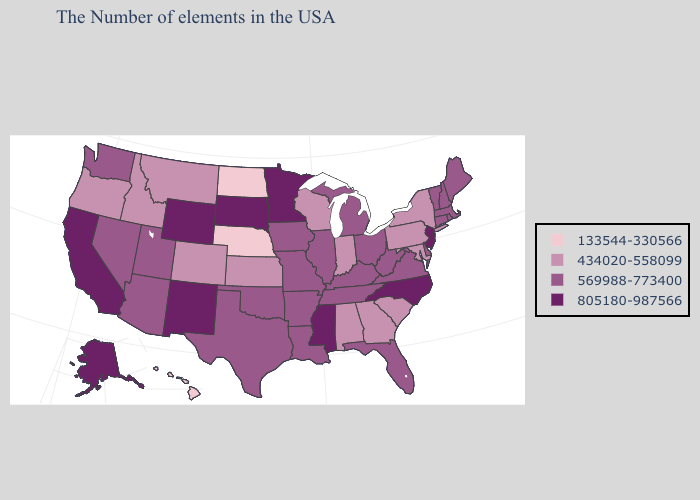Does Iowa have the same value as New York?
Be succinct. No. Name the states that have a value in the range 805180-987566?
Write a very short answer. New Jersey, North Carolina, Mississippi, Minnesota, South Dakota, Wyoming, New Mexico, California, Alaska. Which states have the lowest value in the USA?
Keep it brief. Nebraska, North Dakota, Hawaii. Name the states that have a value in the range 805180-987566?
Answer briefly. New Jersey, North Carolina, Mississippi, Minnesota, South Dakota, Wyoming, New Mexico, California, Alaska. What is the lowest value in the West?
Short answer required. 133544-330566. What is the value of Iowa?
Short answer required. 569988-773400. What is the lowest value in states that border Louisiana?
Give a very brief answer. 569988-773400. Among the states that border Oklahoma , which have the lowest value?
Write a very short answer. Kansas, Colorado. Does Illinois have the highest value in the USA?
Write a very short answer. No. Name the states that have a value in the range 805180-987566?
Write a very short answer. New Jersey, North Carolina, Mississippi, Minnesota, South Dakota, Wyoming, New Mexico, California, Alaska. How many symbols are there in the legend?
Short answer required. 4. Name the states that have a value in the range 434020-558099?
Write a very short answer. New York, Maryland, Pennsylvania, South Carolina, Georgia, Indiana, Alabama, Wisconsin, Kansas, Colorado, Montana, Idaho, Oregon. Is the legend a continuous bar?
Give a very brief answer. No. Which states hav the highest value in the Northeast?
Concise answer only. New Jersey. What is the value of Oregon?
Write a very short answer. 434020-558099. 